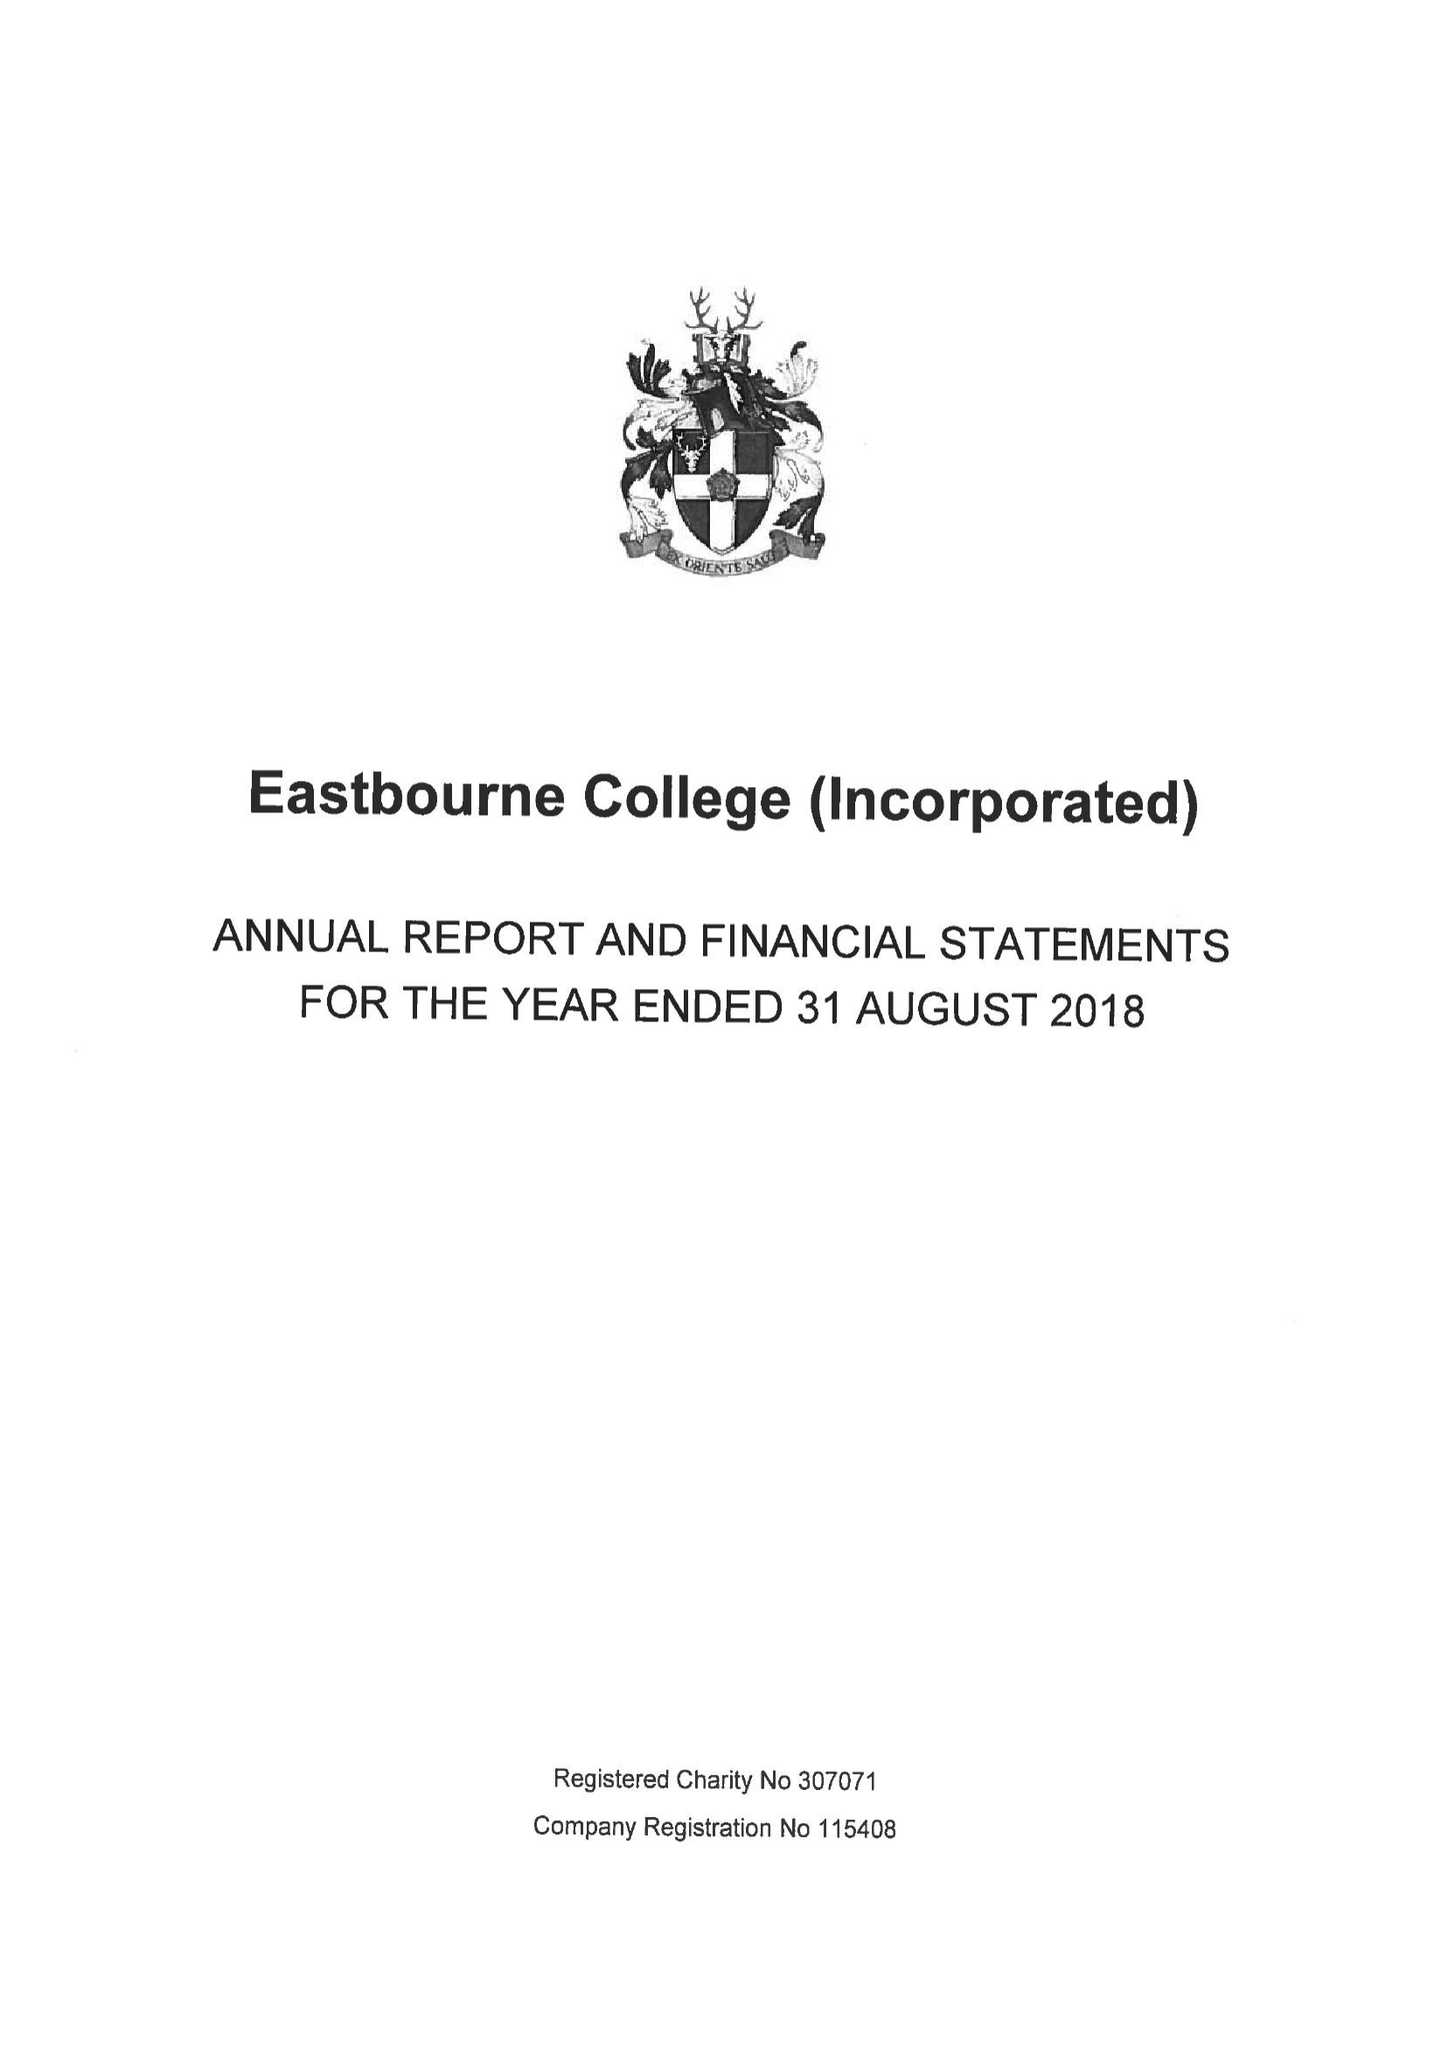What is the value for the spending_annually_in_british_pounds?
Answer the question using a single word or phrase. 22089000.00 